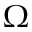Convert formula to latex. <formula><loc_0><loc_0><loc_500><loc_500>\Omega</formula> 